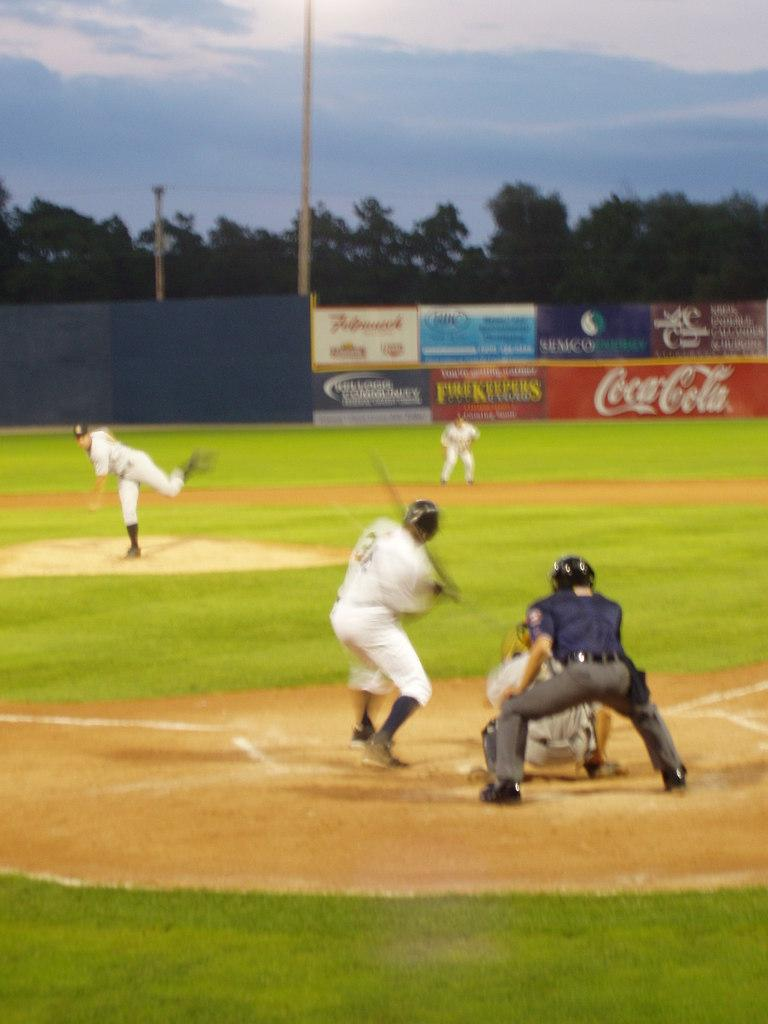<image>
Offer a succinct explanation of the picture presented. A baseball game with advertisements such as Coca-Cola and Firekeepers on the outfield wall. 